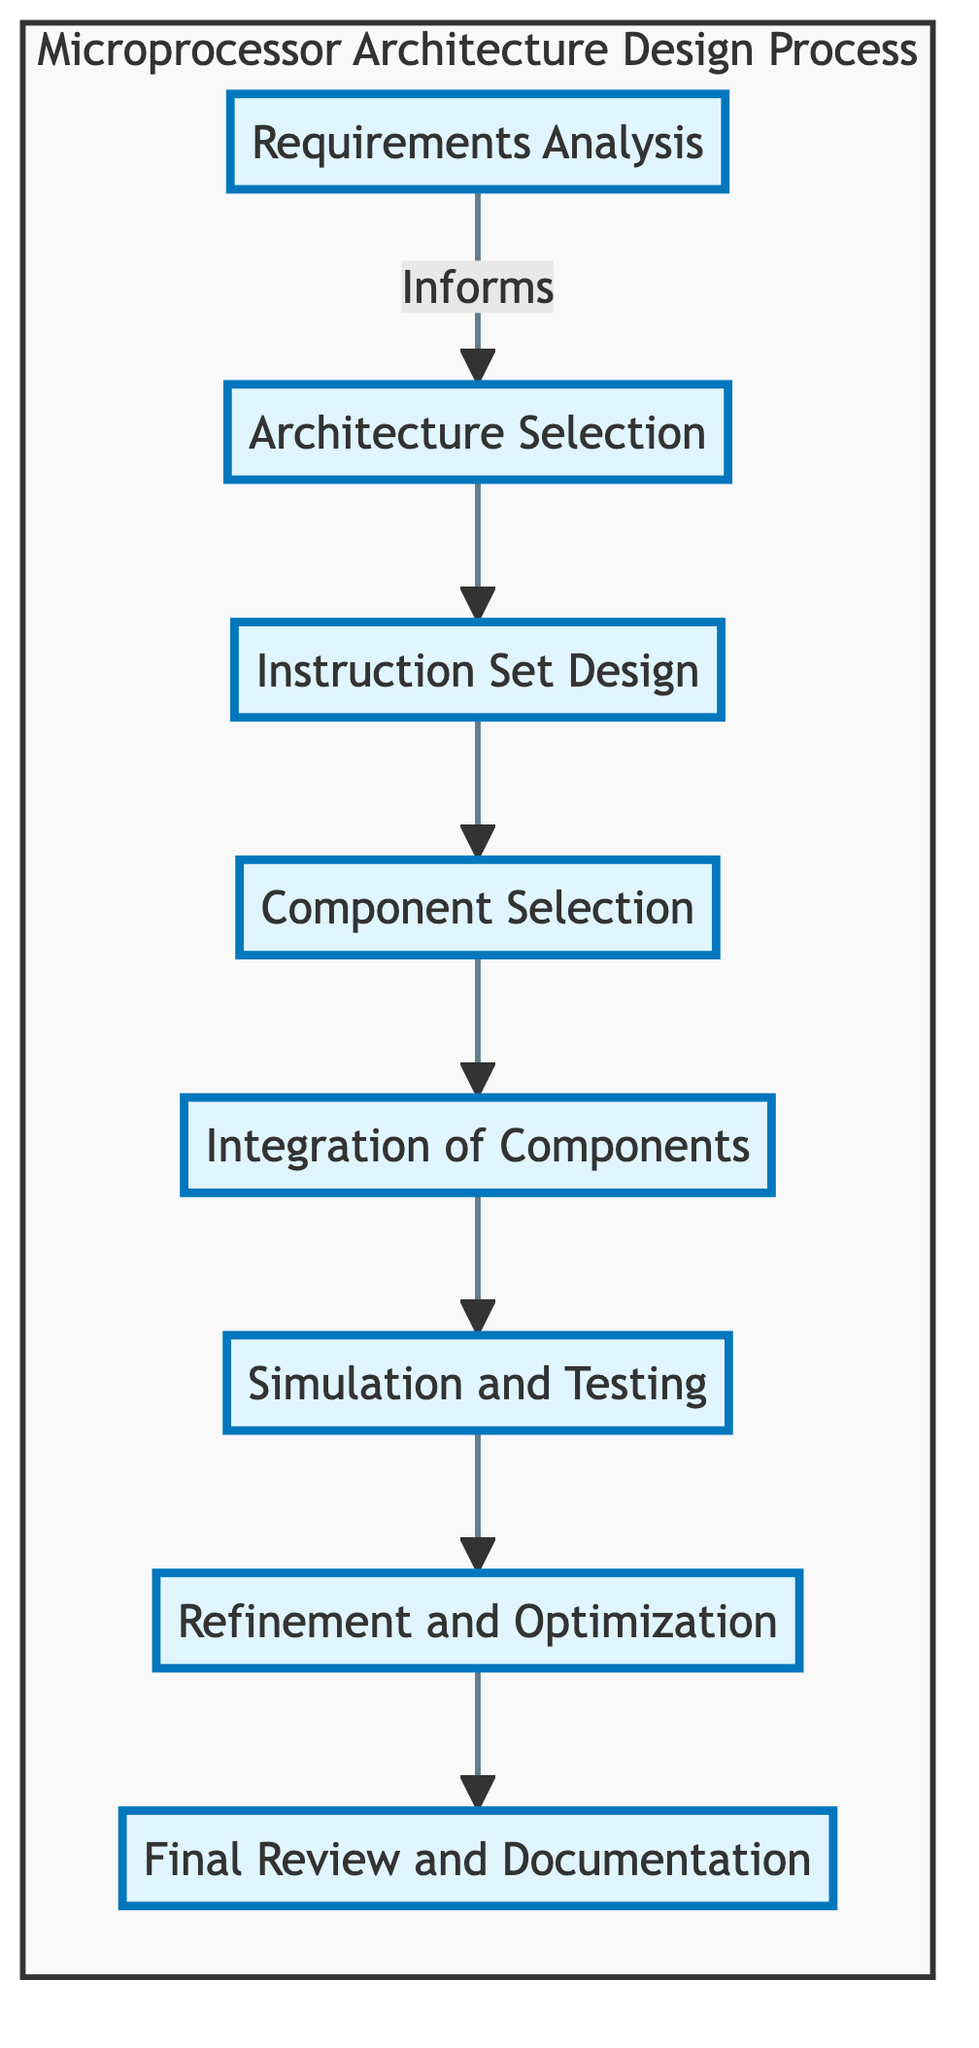What is the first step in the microprocessor architecture design process? The first step, as indicated in the diagram, is "Requirements Analysis," which is where the functional and performance requirements are defined.
Answer: Requirements Analysis How many primary steps are outlined in the diagram? The diagram presents a total of eight steps, which are connected sequentially from the requirements analysis to the final review.
Answer: Eight What follows "Component Selection" in the design process? The next step that follows "Component Selection" is "Integration of Components," where the selected components are combined into a cohesive unit.
Answer: Integration of Components Which step is focused on verifying functionality and performance? The step focused on verifying functionality and performance is "Simulation and Testing," where simulations are created to ensure the design works as intended.
Answer: Simulation and Testing What is the last step of the design process? The last step of the process is "Final Review and Documentation," which involves a review and documentation of the design for future reference.
Answer: Final Review and Documentation What relationship exists between "Instruction Set Design" and "Architecture Selection"? "Architecture Selection" informs the "Instruction Set Design," as the chosen architecture drives the development of the instruction set architecture (ISA).
Answer: Informs Which step involves making adjustments to improve performance? The step that involves making adjustments to improve performance, power consumption, and area is "Refinement and Optimization."
Answer: Refinement and Optimization Which step comes directly after "Simulation and Testing"? The step that comes directly after "Simulation and Testing" is "Refinement and Optimization," indicating that after testing, adjustments are made.
Answer: Refinement and Optimization 